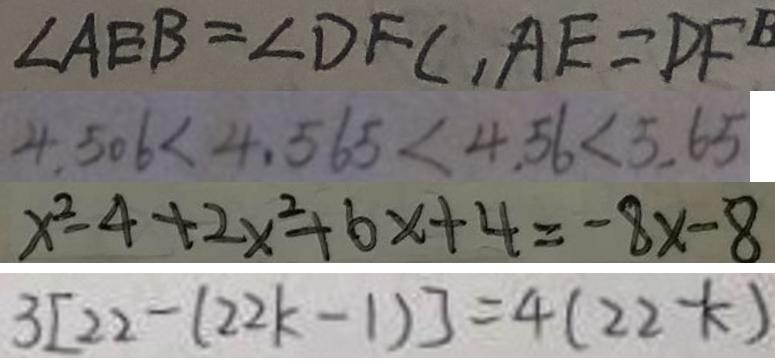Convert formula to latex. <formula><loc_0><loc_0><loc_500><loc_500>\angle A E B = \angle D F C , A E = D F 
 4 . 5 0 6 < 4 . 5 6 5 < 4 . 5 6 < 5 . 6 5 
 x ^ { 2 } - 4 + 2 x ^ { 2 } + 6 x + 4 = - 8 x - 8 
 3 [ 2 2 - ( 2 2 k - 1 ) ] = 4 ( 2 2 - k )</formula> 